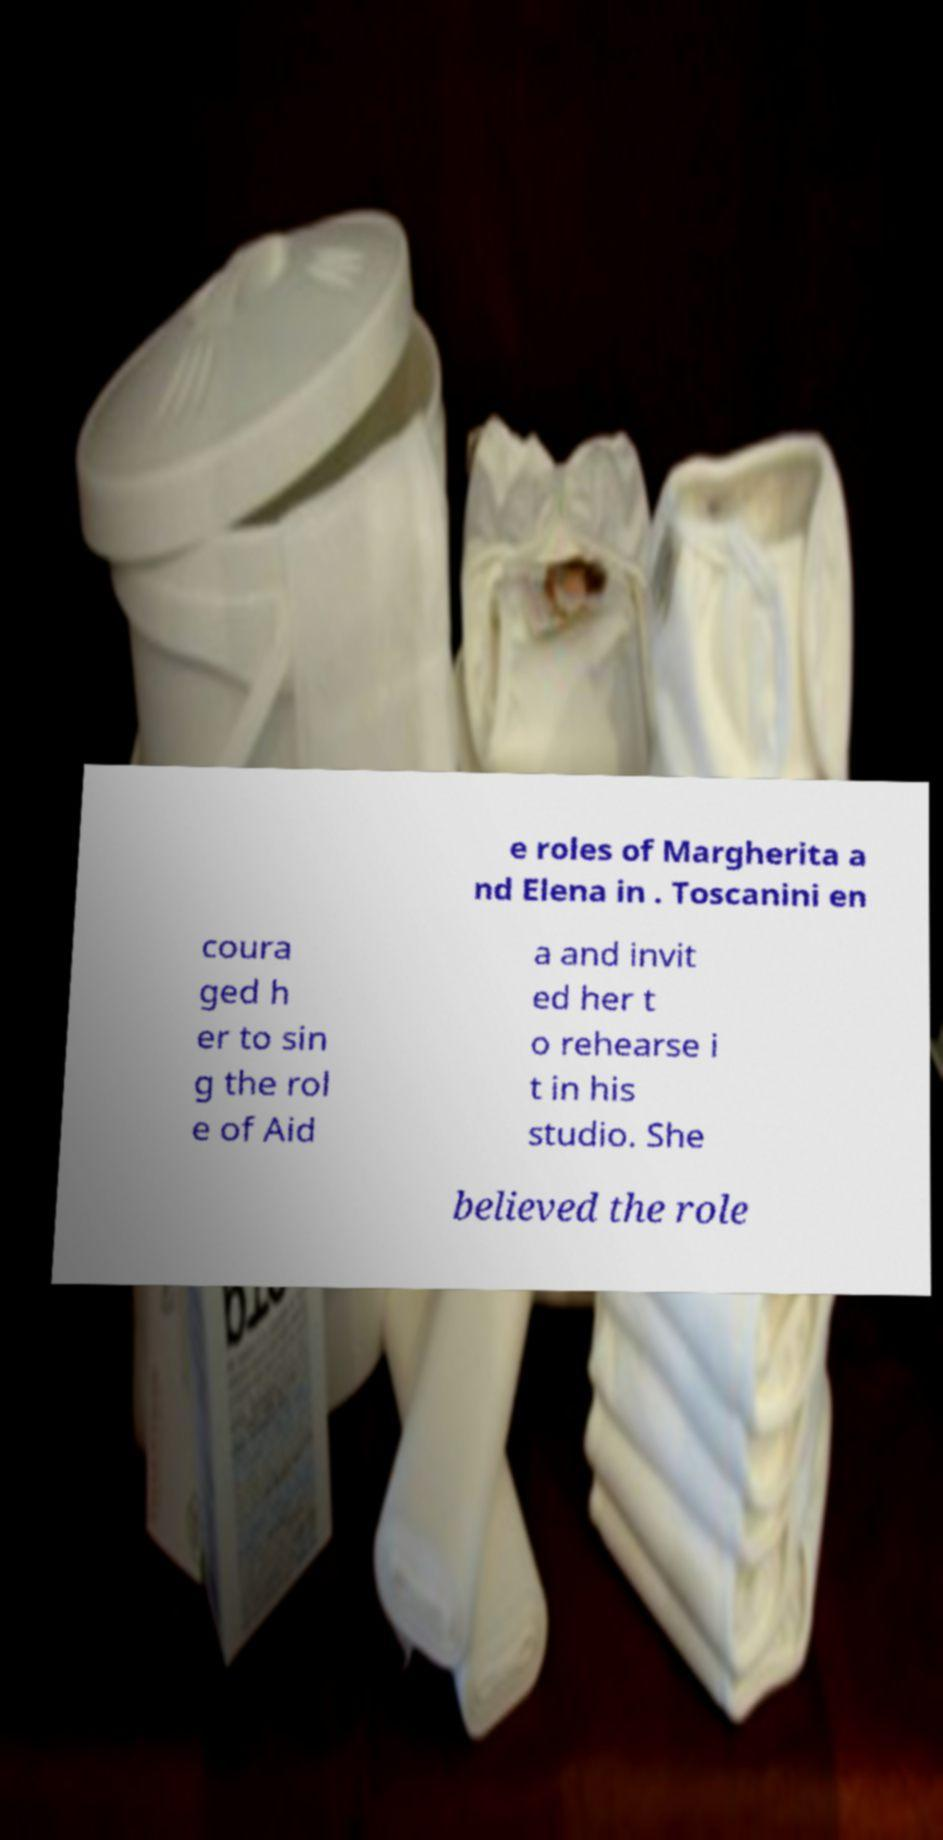Can you accurately transcribe the text from the provided image for me? e roles of Margherita a nd Elena in . Toscanini en coura ged h er to sin g the rol e of Aid a and invit ed her t o rehearse i t in his studio. She believed the role 